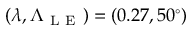Convert formula to latex. <formula><loc_0><loc_0><loc_500><loc_500>( \lambda , \Lambda _ { L E } ) = ( 0 . 2 7 , 5 0 ^ { \circ } )</formula> 